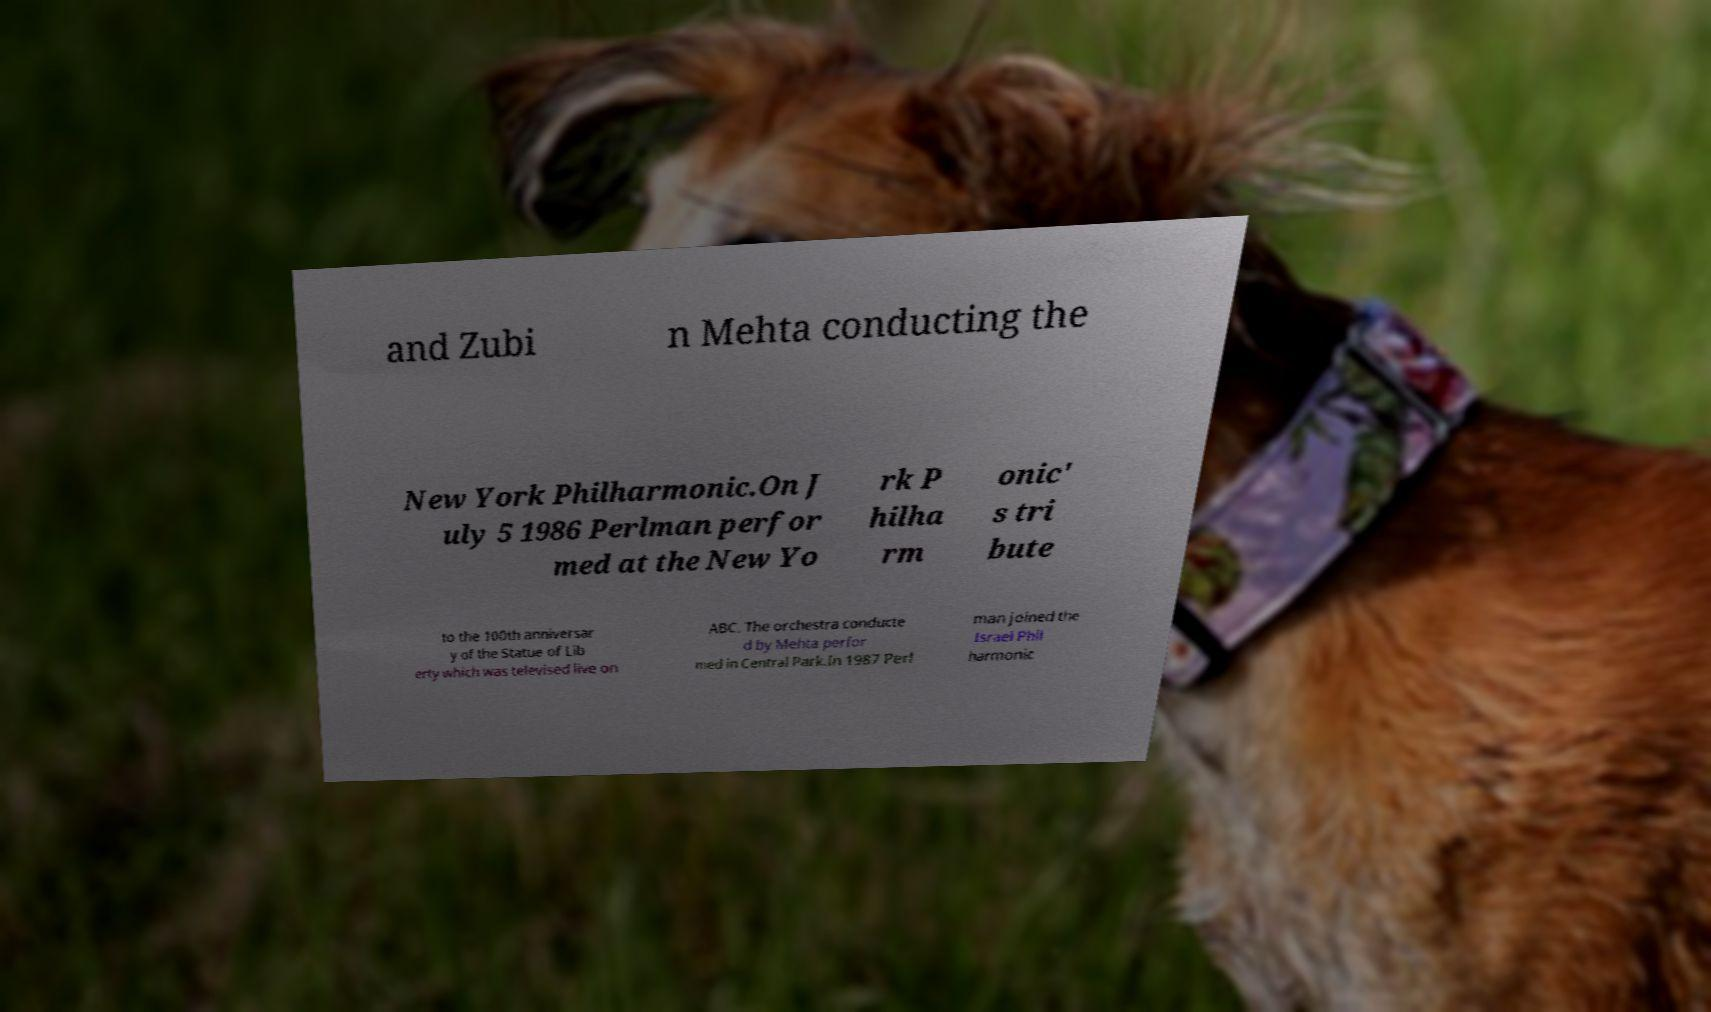I need the written content from this picture converted into text. Can you do that? and Zubi n Mehta conducting the New York Philharmonic.On J uly 5 1986 Perlman perfor med at the New Yo rk P hilha rm onic' s tri bute to the 100th anniversar y of the Statue of Lib erty which was televised live on ABC. The orchestra conducte d by Mehta perfor med in Central Park.In 1987 Perl man joined the Israel Phil harmonic 